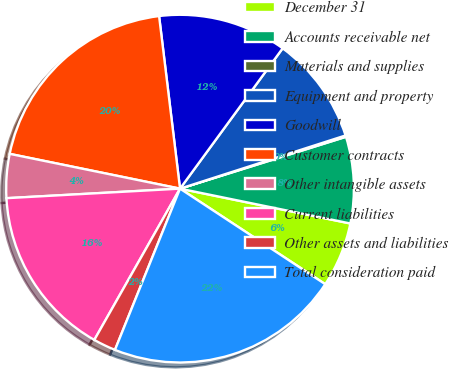Convert chart. <chart><loc_0><loc_0><loc_500><loc_500><pie_chart><fcel>December 31<fcel>Accounts receivable net<fcel>Materials and supplies<fcel>Equipment and property<fcel>Goodwill<fcel>Customer contracts<fcel>Other intangible assets<fcel>Current liabilities<fcel>Other assets and liabilities<fcel>Total consideration paid<nl><fcel>6.05%<fcel>8.03%<fcel>0.13%<fcel>10.0%<fcel>11.97%<fcel>19.87%<fcel>4.08%<fcel>15.92%<fcel>2.1%<fcel>21.84%<nl></chart> 